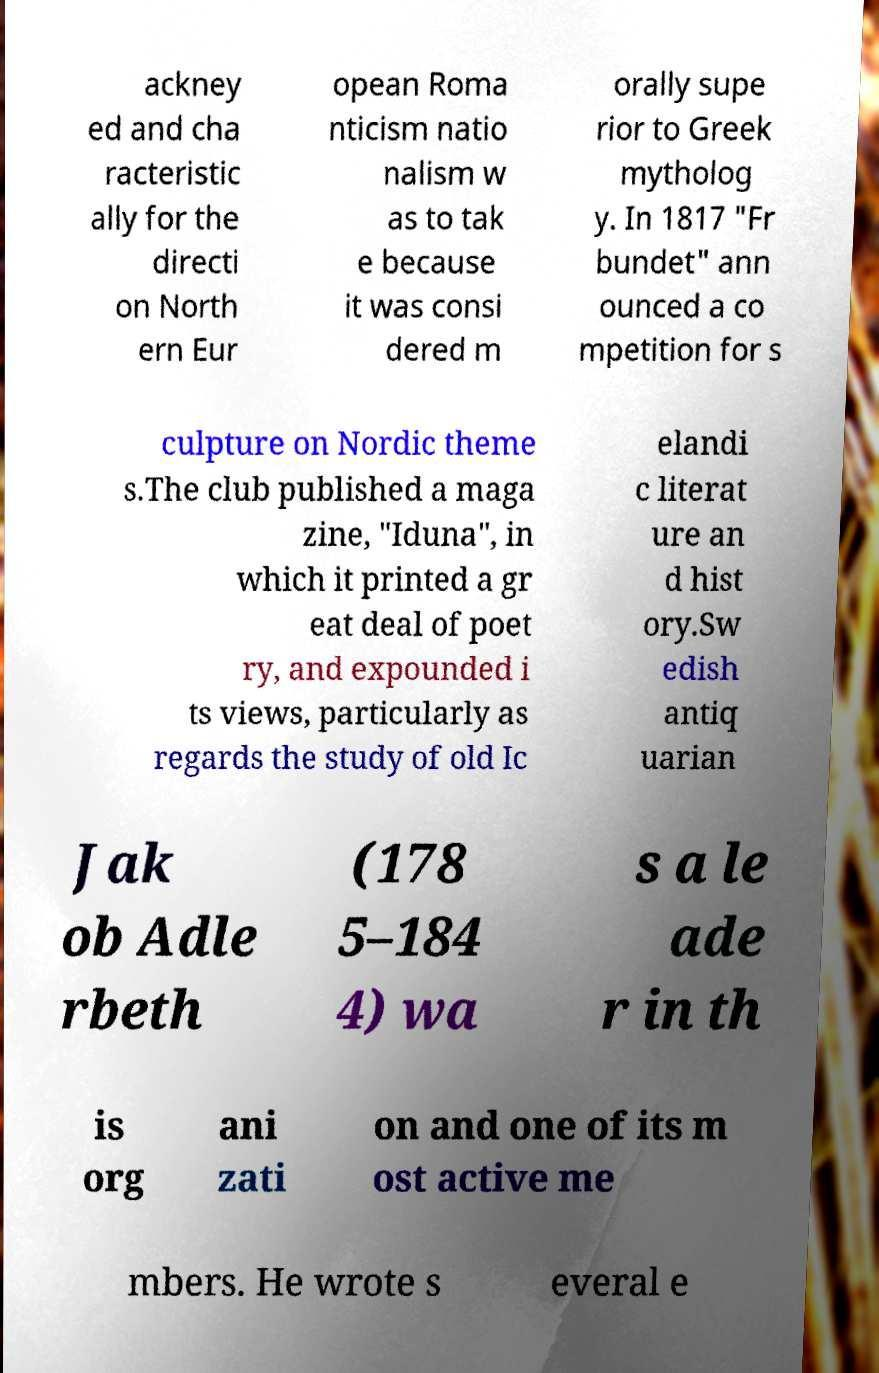Can you read and provide the text displayed in the image?This photo seems to have some interesting text. Can you extract and type it out for me? ackney ed and cha racteristic ally for the directi on North ern Eur opean Roma nticism natio nalism w as to tak e because it was consi dered m orally supe rior to Greek mytholog y. In 1817 "Fr bundet" ann ounced a co mpetition for s culpture on Nordic theme s.The club published a maga zine, "Iduna", in which it printed a gr eat deal of poet ry, and expounded i ts views, particularly as regards the study of old Ic elandi c literat ure an d hist ory.Sw edish antiq uarian Jak ob Adle rbeth (178 5–184 4) wa s a le ade r in th is org ani zati on and one of its m ost active me mbers. He wrote s everal e 